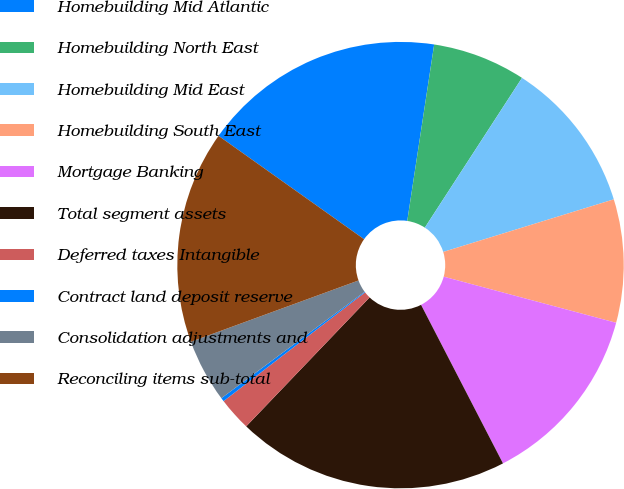Convert chart. <chart><loc_0><loc_0><loc_500><loc_500><pie_chart><fcel>Homebuilding Mid Atlantic<fcel>Homebuilding North East<fcel>Homebuilding Mid East<fcel>Homebuilding South East<fcel>Mortgage Banking<fcel>Total segment assets<fcel>Deferred taxes Intangible<fcel>Contract land deposit reserve<fcel>Consolidation adjustments and<fcel>Reconciling items sub-total<nl><fcel>17.58%<fcel>6.75%<fcel>11.08%<fcel>8.92%<fcel>13.25%<fcel>19.74%<fcel>2.42%<fcel>0.26%<fcel>4.59%<fcel>15.41%<nl></chart> 